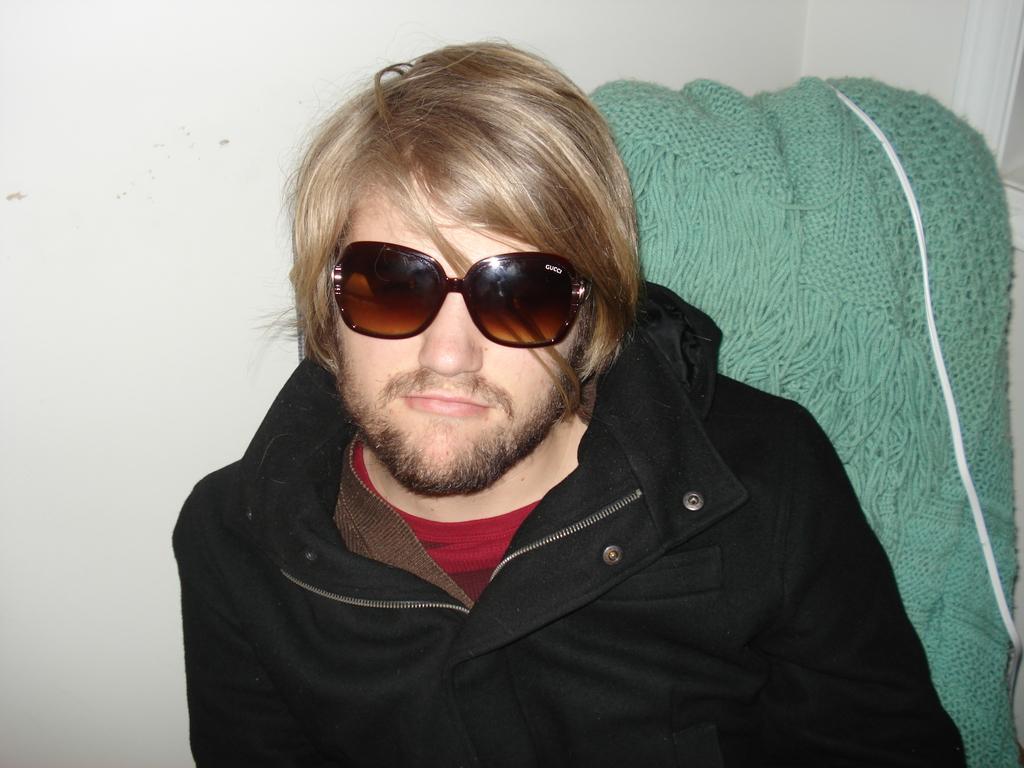How would you summarize this image in a sentence or two? In this we can see a person is wearing goggles and jacket. Background we can see wall, wooden cloth and wire. 